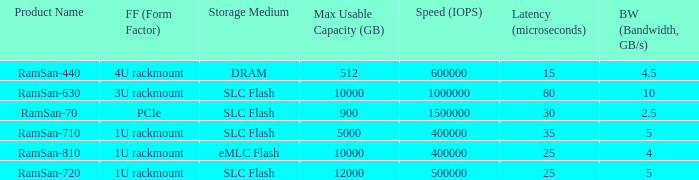What is the Input/output operations per second for the emlc flash? 400000.0. 